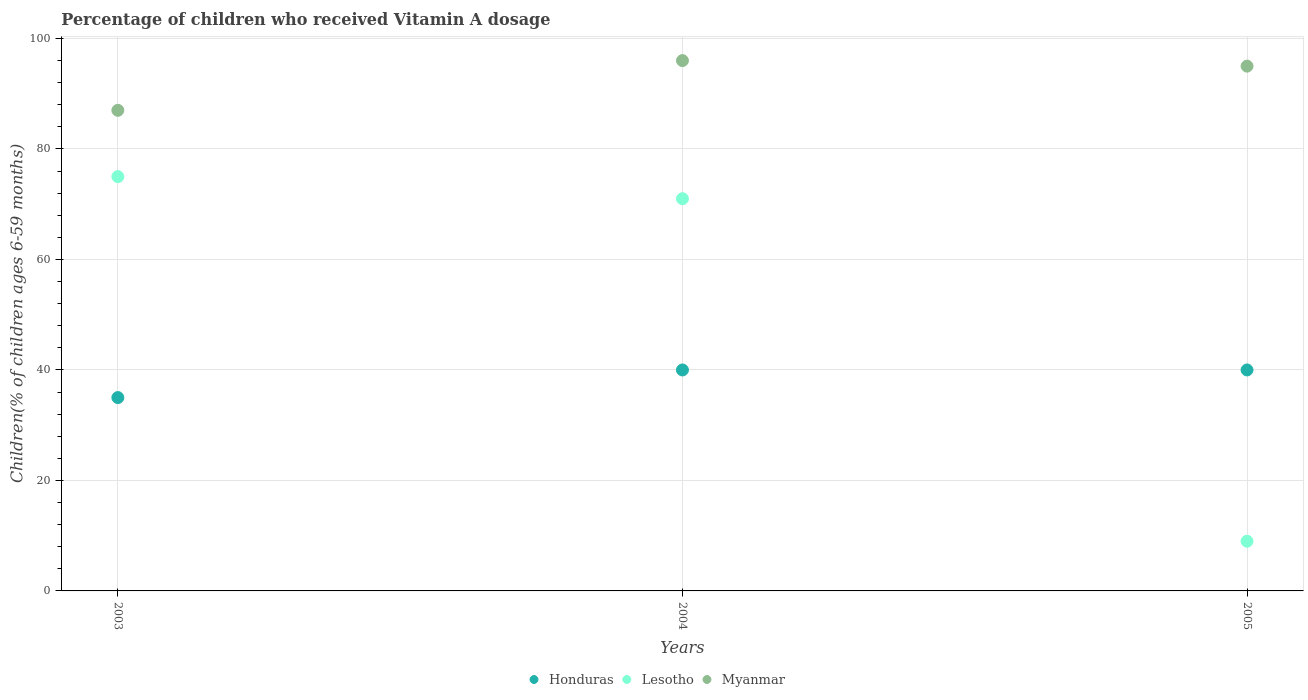In which year was the percentage of children who received Vitamin A dosage in Myanmar maximum?
Offer a terse response. 2004. What is the total percentage of children who received Vitamin A dosage in Honduras in the graph?
Offer a very short reply. 115. What is the difference between the percentage of children who received Vitamin A dosage in Lesotho in 2003 and that in 2004?
Ensure brevity in your answer.  4. What is the difference between the percentage of children who received Vitamin A dosage in Honduras in 2004 and the percentage of children who received Vitamin A dosage in Myanmar in 2005?
Provide a succinct answer. -55. What is the average percentage of children who received Vitamin A dosage in Myanmar per year?
Make the answer very short. 92.67. In the year 2004, what is the difference between the percentage of children who received Vitamin A dosage in Honduras and percentage of children who received Vitamin A dosage in Lesotho?
Offer a very short reply. -31. In how many years, is the percentage of children who received Vitamin A dosage in Myanmar greater than 12 %?
Provide a succinct answer. 3. What is the ratio of the percentage of children who received Vitamin A dosage in Lesotho in 2003 to that in 2005?
Make the answer very short. 8.33. Is the percentage of children who received Vitamin A dosage in Myanmar in 2003 less than that in 2005?
Your answer should be very brief. Yes. Is the difference between the percentage of children who received Vitamin A dosage in Honduras in 2003 and 2005 greater than the difference between the percentage of children who received Vitamin A dosage in Lesotho in 2003 and 2005?
Your response must be concise. No. What is the difference between the highest and the second highest percentage of children who received Vitamin A dosage in Myanmar?
Make the answer very short. 1. Is the sum of the percentage of children who received Vitamin A dosage in Myanmar in 2003 and 2004 greater than the maximum percentage of children who received Vitamin A dosage in Lesotho across all years?
Offer a very short reply. Yes. Is it the case that in every year, the sum of the percentage of children who received Vitamin A dosage in Myanmar and percentage of children who received Vitamin A dosage in Lesotho  is greater than the percentage of children who received Vitamin A dosage in Honduras?
Provide a succinct answer. Yes. Does the percentage of children who received Vitamin A dosage in Myanmar monotonically increase over the years?
Provide a short and direct response. No. Is the percentage of children who received Vitamin A dosage in Lesotho strictly greater than the percentage of children who received Vitamin A dosage in Honduras over the years?
Provide a succinct answer. No. Are the values on the major ticks of Y-axis written in scientific E-notation?
Make the answer very short. No. Where does the legend appear in the graph?
Your response must be concise. Bottom center. What is the title of the graph?
Keep it short and to the point. Percentage of children who received Vitamin A dosage. What is the label or title of the Y-axis?
Keep it short and to the point. Children(% of children ages 6-59 months). What is the Children(% of children ages 6-59 months) in Lesotho in 2003?
Offer a very short reply. 75. What is the Children(% of children ages 6-59 months) in Myanmar in 2003?
Offer a terse response. 87. What is the Children(% of children ages 6-59 months) in Honduras in 2004?
Ensure brevity in your answer.  40. What is the Children(% of children ages 6-59 months) of Myanmar in 2004?
Provide a short and direct response. 96. Across all years, what is the maximum Children(% of children ages 6-59 months) in Myanmar?
Give a very brief answer. 96. Across all years, what is the minimum Children(% of children ages 6-59 months) in Myanmar?
Your response must be concise. 87. What is the total Children(% of children ages 6-59 months) of Honduras in the graph?
Ensure brevity in your answer.  115. What is the total Children(% of children ages 6-59 months) in Lesotho in the graph?
Your answer should be very brief. 155. What is the total Children(% of children ages 6-59 months) of Myanmar in the graph?
Provide a succinct answer. 278. What is the difference between the Children(% of children ages 6-59 months) of Honduras in 2003 and that in 2004?
Make the answer very short. -5. What is the difference between the Children(% of children ages 6-59 months) in Lesotho in 2003 and that in 2004?
Your answer should be compact. 4. What is the difference between the Children(% of children ages 6-59 months) in Honduras in 2003 and that in 2005?
Provide a short and direct response. -5. What is the difference between the Children(% of children ages 6-59 months) of Lesotho in 2003 and that in 2005?
Ensure brevity in your answer.  66. What is the difference between the Children(% of children ages 6-59 months) in Honduras in 2004 and that in 2005?
Offer a very short reply. 0. What is the difference between the Children(% of children ages 6-59 months) of Lesotho in 2004 and that in 2005?
Provide a succinct answer. 62. What is the difference between the Children(% of children ages 6-59 months) of Honduras in 2003 and the Children(% of children ages 6-59 months) of Lesotho in 2004?
Your answer should be compact. -36. What is the difference between the Children(% of children ages 6-59 months) in Honduras in 2003 and the Children(% of children ages 6-59 months) in Myanmar in 2004?
Offer a very short reply. -61. What is the difference between the Children(% of children ages 6-59 months) of Lesotho in 2003 and the Children(% of children ages 6-59 months) of Myanmar in 2004?
Keep it short and to the point. -21. What is the difference between the Children(% of children ages 6-59 months) in Honduras in 2003 and the Children(% of children ages 6-59 months) in Lesotho in 2005?
Your response must be concise. 26. What is the difference between the Children(% of children ages 6-59 months) in Honduras in 2003 and the Children(% of children ages 6-59 months) in Myanmar in 2005?
Your answer should be compact. -60. What is the difference between the Children(% of children ages 6-59 months) in Honduras in 2004 and the Children(% of children ages 6-59 months) in Lesotho in 2005?
Give a very brief answer. 31. What is the difference between the Children(% of children ages 6-59 months) of Honduras in 2004 and the Children(% of children ages 6-59 months) of Myanmar in 2005?
Make the answer very short. -55. What is the difference between the Children(% of children ages 6-59 months) in Lesotho in 2004 and the Children(% of children ages 6-59 months) in Myanmar in 2005?
Offer a terse response. -24. What is the average Children(% of children ages 6-59 months) of Honduras per year?
Your answer should be compact. 38.33. What is the average Children(% of children ages 6-59 months) in Lesotho per year?
Your answer should be very brief. 51.67. What is the average Children(% of children ages 6-59 months) of Myanmar per year?
Make the answer very short. 92.67. In the year 2003, what is the difference between the Children(% of children ages 6-59 months) of Honduras and Children(% of children ages 6-59 months) of Lesotho?
Give a very brief answer. -40. In the year 2003, what is the difference between the Children(% of children ages 6-59 months) in Honduras and Children(% of children ages 6-59 months) in Myanmar?
Your answer should be compact. -52. In the year 2004, what is the difference between the Children(% of children ages 6-59 months) of Honduras and Children(% of children ages 6-59 months) of Lesotho?
Offer a very short reply. -31. In the year 2004, what is the difference between the Children(% of children ages 6-59 months) of Honduras and Children(% of children ages 6-59 months) of Myanmar?
Make the answer very short. -56. In the year 2004, what is the difference between the Children(% of children ages 6-59 months) in Lesotho and Children(% of children ages 6-59 months) in Myanmar?
Offer a terse response. -25. In the year 2005, what is the difference between the Children(% of children ages 6-59 months) of Honduras and Children(% of children ages 6-59 months) of Lesotho?
Provide a short and direct response. 31. In the year 2005, what is the difference between the Children(% of children ages 6-59 months) in Honduras and Children(% of children ages 6-59 months) in Myanmar?
Give a very brief answer. -55. In the year 2005, what is the difference between the Children(% of children ages 6-59 months) of Lesotho and Children(% of children ages 6-59 months) of Myanmar?
Offer a terse response. -86. What is the ratio of the Children(% of children ages 6-59 months) of Lesotho in 2003 to that in 2004?
Your answer should be very brief. 1.06. What is the ratio of the Children(% of children ages 6-59 months) in Myanmar in 2003 to that in 2004?
Give a very brief answer. 0.91. What is the ratio of the Children(% of children ages 6-59 months) in Lesotho in 2003 to that in 2005?
Keep it short and to the point. 8.33. What is the ratio of the Children(% of children ages 6-59 months) of Myanmar in 2003 to that in 2005?
Keep it short and to the point. 0.92. What is the ratio of the Children(% of children ages 6-59 months) in Lesotho in 2004 to that in 2005?
Offer a very short reply. 7.89. What is the ratio of the Children(% of children ages 6-59 months) of Myanmar in 2004 to that in 2005?
Offer a terse response. 1.01. What is the difference between the highest and the second highest Children(% of children ages 6-59 months) in Myanmar?
Provide a succinct answer. 1. 